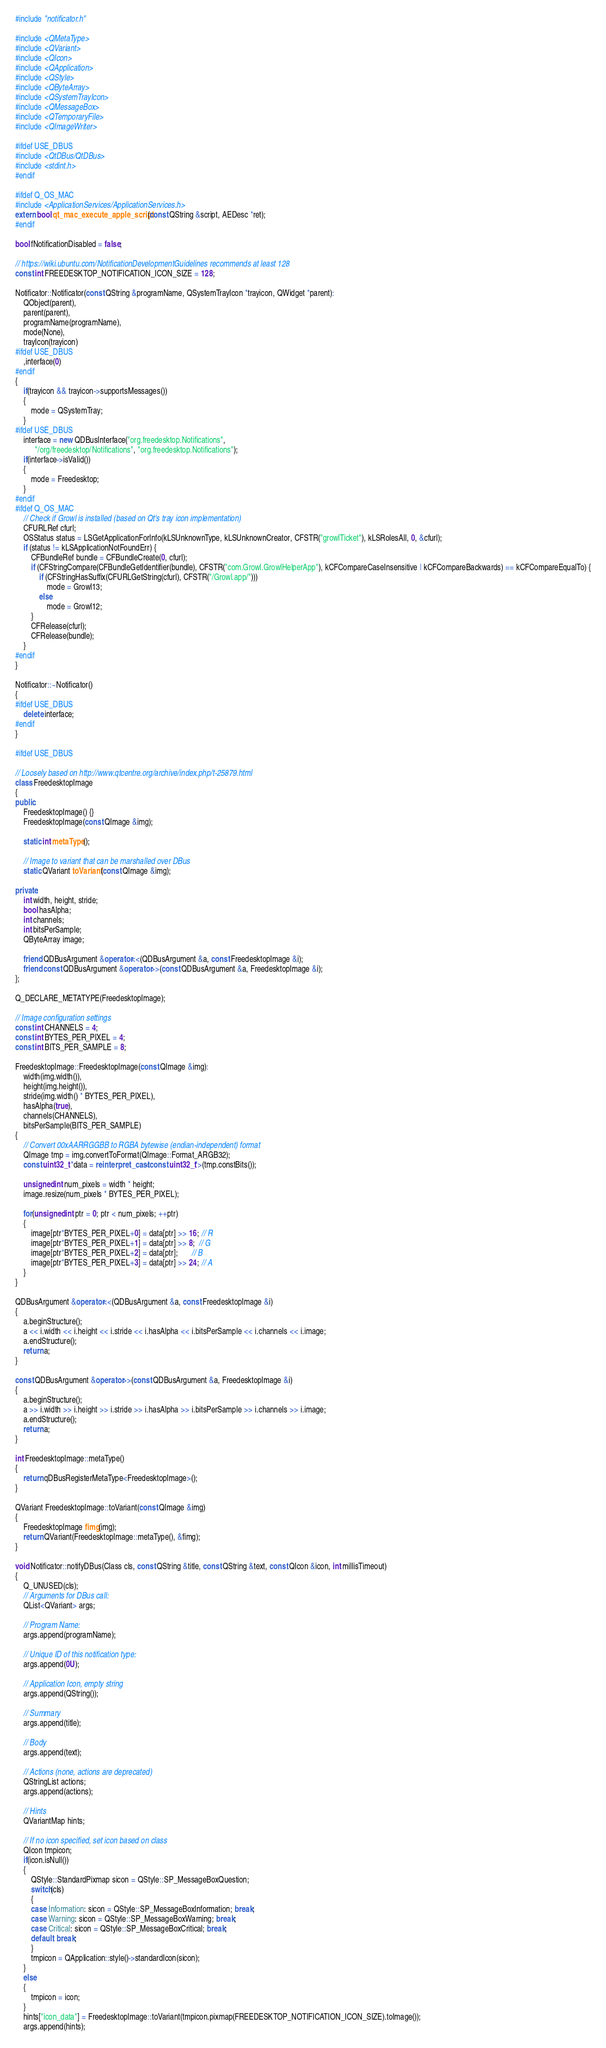<code> <loc_0><loc_0><loc_500><loc_500><_C++_>#include "notificator.h"

#include <QMetaType>
#include <QVariant>
#include <QIcon>
#include <QApplication>
#include <QStyle>
#include <QByteArray>
#include <QSystemTrayIcon>
#include <QMessageBox>
#include <QTemporaryFile>
#include <QImageWriter>

#ifdef USE_DBUS
#include <QtDBus/QtDBus>
#include <stdint.h>
#endif

#ifdef Q_OS_MAC
#include <ApplicationServices/ApplicationServices.h>
extern bool qt_mac_execute_apple_script(const QString &script, AEDesc *ret);
#endif

bool fNotificationDisabled = false;

// https://wiki.ubuntu.com/NotificationDevelopmentGuidelines recommends at least 128
const int FREEDESKTOP_NOTIFICATION_ICON_SIZE = 128;

Notificator::Notificator(const QString &programName, QSystemTrayIcon *trayicon, QWidget *parent):
    QObject(parent),
    parent(parent),
    programName(programName),
    mode(None),
    trayIcon(trayicon)
#ifdef USE_DBUS
    ,interface(0)
#endif
{
    if(trayicon && trayicon->supportsMessages())
    {
        mode = QSystemTray;
    }
#ifdef USE_DBUS
    interface = new QDBusInterface("org.freedesktop.Notifications",
          "/org/freedesktop/Notifications", "org.freedesktop.Notifications");
    if(interface->isValid())
    {
        mode = Freedesktop;
    }
#endif
#ifdef Q_OS_MAC
    // Check if Growl is installed (based on Qt's tray icon implementation)
    CFURLRef cfurl;
    OSStatus status = LSGetApplicationForInfo(kLSUnknownType, kLSUnknownCreator, CFSTR("growlTicket"), kLSRolesAll, 0, &cfurl);
    if (status != kLSApplicationNotFoundErr) {
        CFBundleRef bundle = CFBundleCreate(0, cfurl);
        if (CFStringCompare(CFBundleGetIdentifier(bundle), CFSTR("com.Growl.GrowlHelperApp"), kCFCompareCaseInsensitive | kCFCompareBackwards) == kCFCompareEqualTo) {
            if (CFStringHasSuffix(CFURLGetString(cfurl), CFSTR("/Growl.app/")))
                mode = Growl13;
            else
                mode = Growl12;
        }
        CFRelease(cfurl);
        CFRelease(bundle);
    }
#endif
}

Notificator::~Notificator()
{
#ifdef USE_DBUS
    delete interface;
#endif
}

#ifdef USE_DBUS

// Loosely based on http://www.qtcentre.org/archive/index.php/t-25879.html
class FreedesktopImage
{
public:
    FreedesktopImage() {}
    FreedesktopImage(const QImage &img);

    static int metaType();

    // Image to variant that can be marshalled over DBus
    static QVariant toVariant(const QImage &img);

private:
    int width, height, stride;
    bool hasAlpha;
    int channels;
    int bitsPerSample;
    QByteArray image;

    friend QDBusArgument &operator<<(QDBusArgument &a, const FreedesktopImage &i);
    friend const QDBusArgument &operator>>(const QDBusArgument &a, FreedesktopImage &i);
};

Q_DECLARE_METATYPE(FreedesktopImage);

// Image configuration settings
const int CHANNELS = 4;
const int BYTES_PER_PIXEL = 4;
const int BITS_PER_SAMPLE = 8;

FreedesktopImage::FreedesktopImage(const QImage &img):
    width(img.width()),
    height(img.height()),
    stride(img.width() * BYTES_PER_PIXEL),
    hasAlpha(true),
    channels(CHANNELS),
    bitsPerSample(BITS_PER_SAMPLE)
{
    // Convert 00xAARRGGBB to RGBA bytewise (endian-independent) format
    QImage tmp = img.convertToFormat(QImage::Format_ARGB32);
    const uint32_t *data = reinterpret_cast<const uint32_t*>(tmp.constBits());

    unsigned int num_pixels = width * height;
    image.resize(num_pixels * BYTES_PER_PIXEL);

    for(unsigned int ptr = 0; ptr < num_pixels; ++ptr)
    {
        image[ptr*BYTES_PER_PIXEL+0] = data[ptr] >> 16; // R
        image[ptr*BYTES_PER_PIXEL+1] = data[ptr] >> 8;  // G
        image[ptr*BYTES_PER_PIXEL+2] = data[ptr];       // B
        image[ptr*BYTES_PER_PIXEL+3] = data[ptr] >> 24; // A
    }
}

QDBusArgument &operator<<(QDBusArgument &a, const FreedesktopImage &i)
{
    a.beginStructure();
    a << i.width << i.height << i.stride << i.hasAlpha << i.bitsPerSample << i.channels << i.image;
    a.endStructure();
    return a;
}

const QDBusArgument &operator>>(const QDBusArgument &a, FreedesktopImage &i)
{
    a.beginStructure();
    a >> i.width >> i.height >> i.stride >> i.hasAlpha >> i.bitsPerSample >> i.channels >> i.image;
    a.endStructure();
    return a;
}

int FreedesktopImage::metaType()
{
    return qDBusRegisterMetaType<FreedesktopImage>();
}

QVariant FreedesktopImage::toVariant(const QImage &img)
{
    FreedesktopImage fimg(img);
    return QVariant(FreedesktopImage::metaType(), &fimg);
}

void Notificator::notifyDBus(Class cls, const QString &title, const QString &text, const QIcon &icon, int millisTimeout)
{
    Q_UNUSED(cls);
    // Arguments for DBus call:
    QList<QVariant> args;

    // Program Name:
    args.append(programName);

    // Unique ID of this notification type:
    args.append(0U);

    // Application Icon, empty string
    args.append(QString());

    // Summary
    args.append(title);

    // Body
    args.append(text);

    // Actions (none, actions are deprecated)
    QStringList actions;
    args.append(actions);

    // Hints
    QVariantMap hints;

    // If no icon specified, set icon based on class
    QIcon tmpicon;
    if(icon.isNull())
    {
        QStyle::StandardPixmap sicon = QStyle::SP_MessageBoxQuestion;
        switch(cls)
        {
        case Information: sicon = QStyle::SP_MessageBoxInformation; break;
        case Warning: sicon = QStyle::SP_MessageBoxWarning; break;
        case Critical: sicon = QStyle::SP_MessageBoxCritical; break;
        default: break;
        }
        tmpicon = QApplication::style()->standardIcon(sicon);
    }
    else
    {
        tmpicon = icon;
    }
    hints["icon_data"] = FreedesktopImage::toVariant(tmpicon.pixmap(FREEDESKTOP_NOTIFICATION_ICON_SIZE).toImage());
    args.append(hints);
</code> 